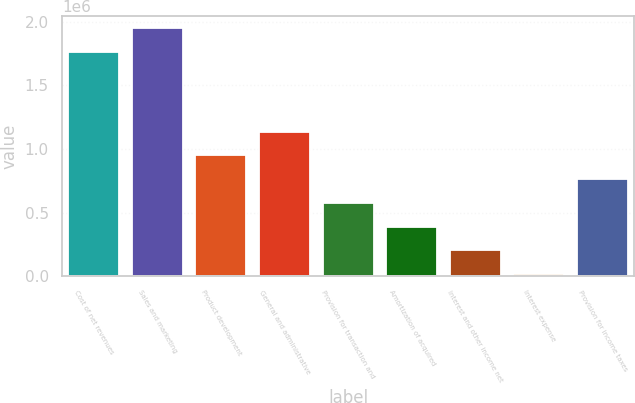Convert chart to OTSL. <chart><loc_0><loc_0><loc_500><loc_500><bar_chart><fcel>Cost of net revenues<fcel>Sales and marketing<fcel>Product development<fcel>General and administrative<fcel>Provision for transaction and<fcel>Amortization of acquired<fcel>Interest and other income net<fcel>Interest expense<fcel>Provision for income taxes<nl><fcel>1.76297e+06<fcel>1.94959e+06<fcel>949705<fcel>1.13633e+06<fcel>576463<fcel>389842<fcel>203221<fcel>16600<fcel>763084<nl></chart> 